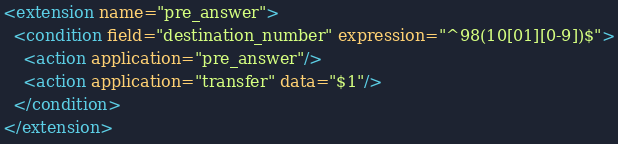<code> <loc_0><loc_0><loc_500><loc_500><_XML_><extension name="pre_answer">
  <condition field="destination_number" expression="^98(10[01][0-9])$">
    <action application="pre_answer"/>
    <action application="transfer" data="$1"/>  
  </condition>
</extension>

</code> 